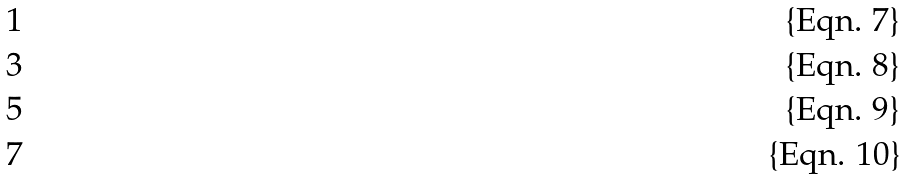Convert formula to latex. <formula><loc_0><loc_0><loc_500><loc_500>1 \\ 3 \\ 5 \\ 7</formula> 